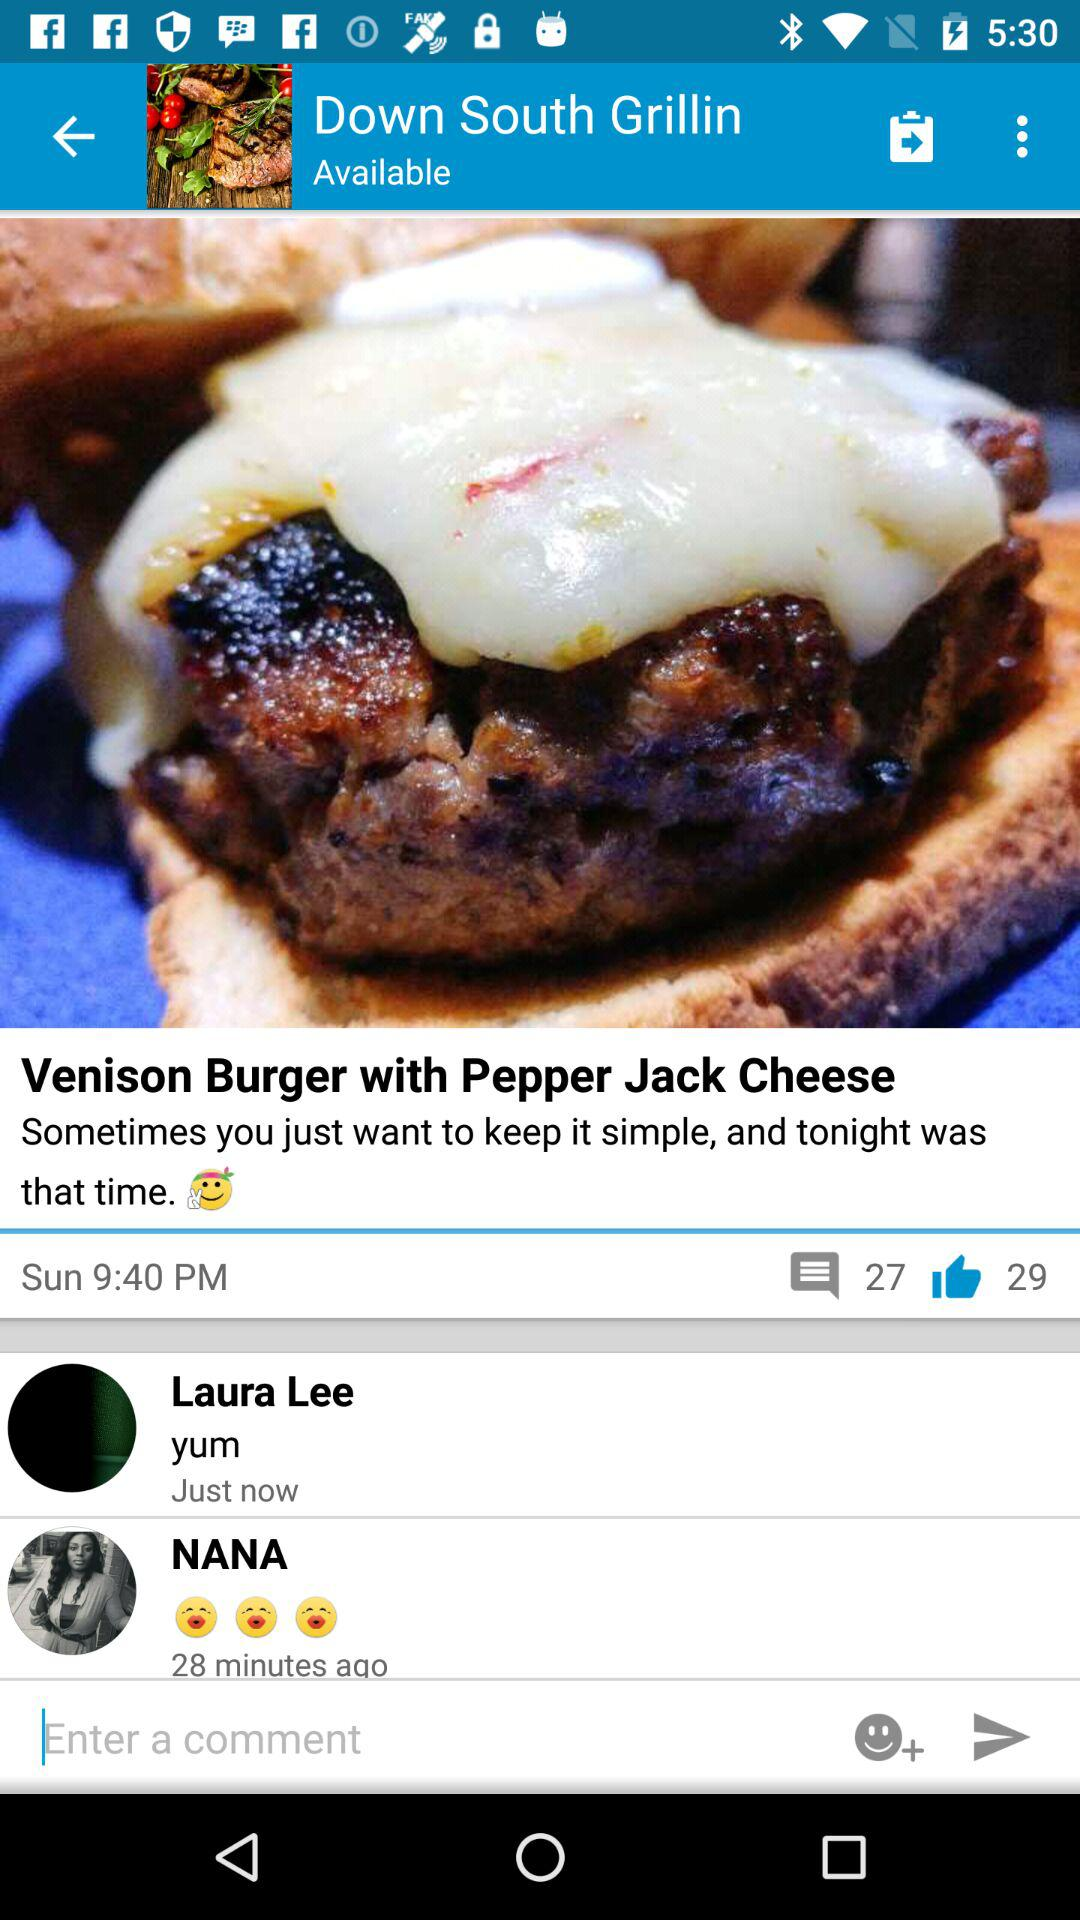How many people commented for the "Venison Burger with Pepper Jack Cheese"? The number of people who commented for the "Venison Burger with Pepper Jack Cheese" is 27. 